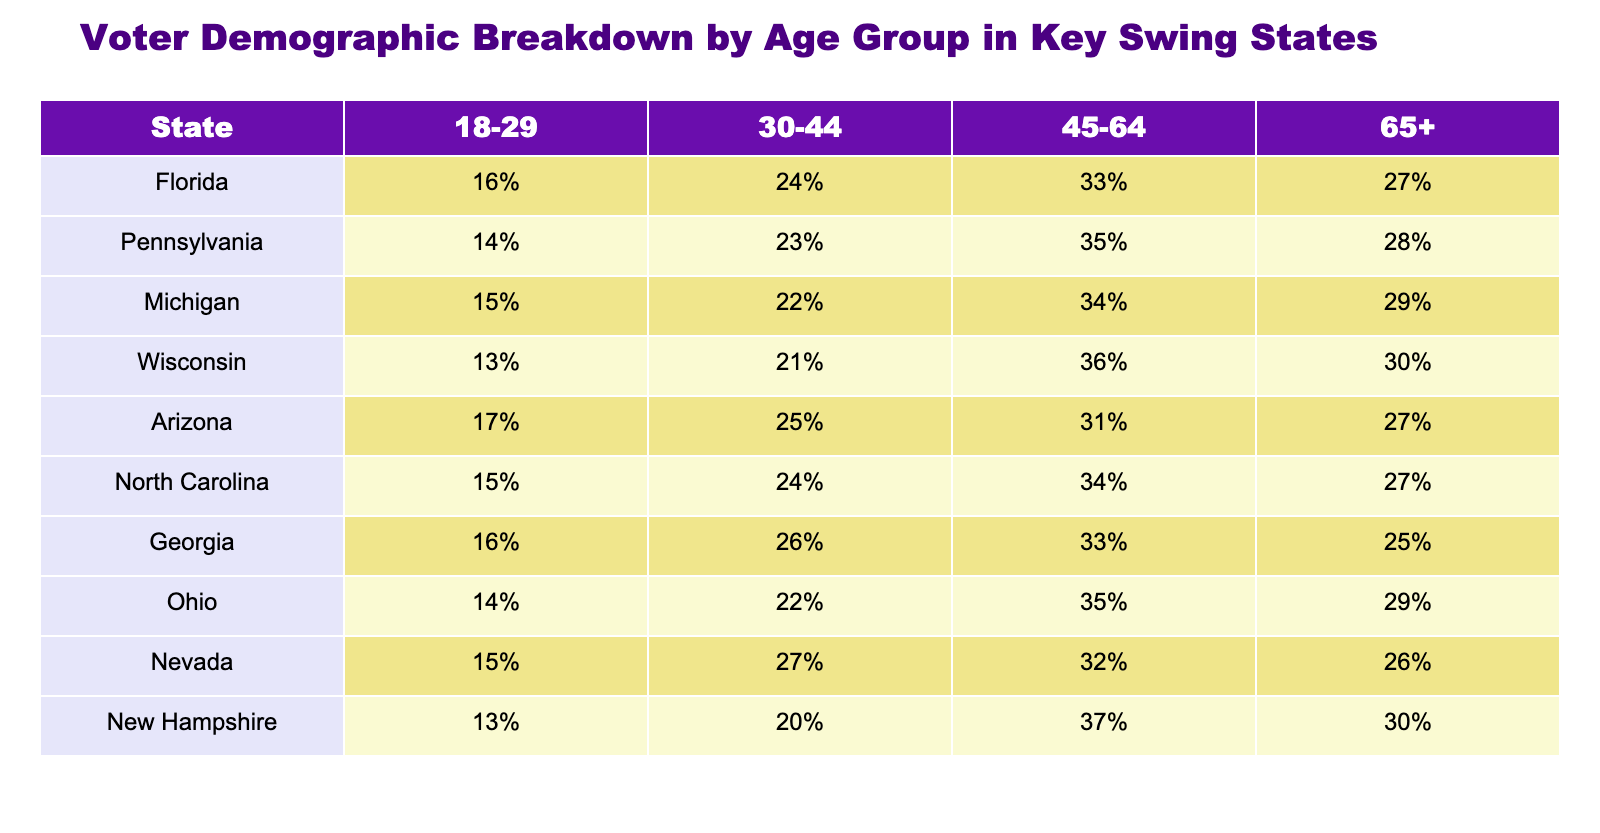What percentage of voters in Florida are aged 30-44? The table shows that Florida has 24% of its voters in the age group 30-44. We can find this in the "Florida" row under the "30-44" column.
Answer: 24% Which state has the highest percentage of voters aged 65 and older? By comparing the percentages in the "65+" column for each state, we can see that Wisconsin has the highest percentage at 30%.
Answer: Wisconsin What is the average percentage of voters aged 18-29 across all states? To find the average, we need to sum the percentages for each state in the "18-29" column: (16 + 14 + 15 + 13 + 17 + 15 + 16 + 14 + 15 + 13) =  15.4. Then, we divide by the total number of states, which is 10: 15.4/10 = 1.54.
Answer: 15.4% Is the percentage of voters aged 45-64 higher in Pennsylvania than in Arizona? The table shows that Pennsylvania has 35% of its voters aged 45-64, while Arizona has 31%. Since 35 is greater than 31, the statement is true.
Answer: Yes Which age group has the highest representation in North Carolina? Looking at the "North Carolina" row, the age group with the highest percentage is 45-64 with 34%. This is determined by comparing all the age group percentages in that row.
Answer: 45-64 